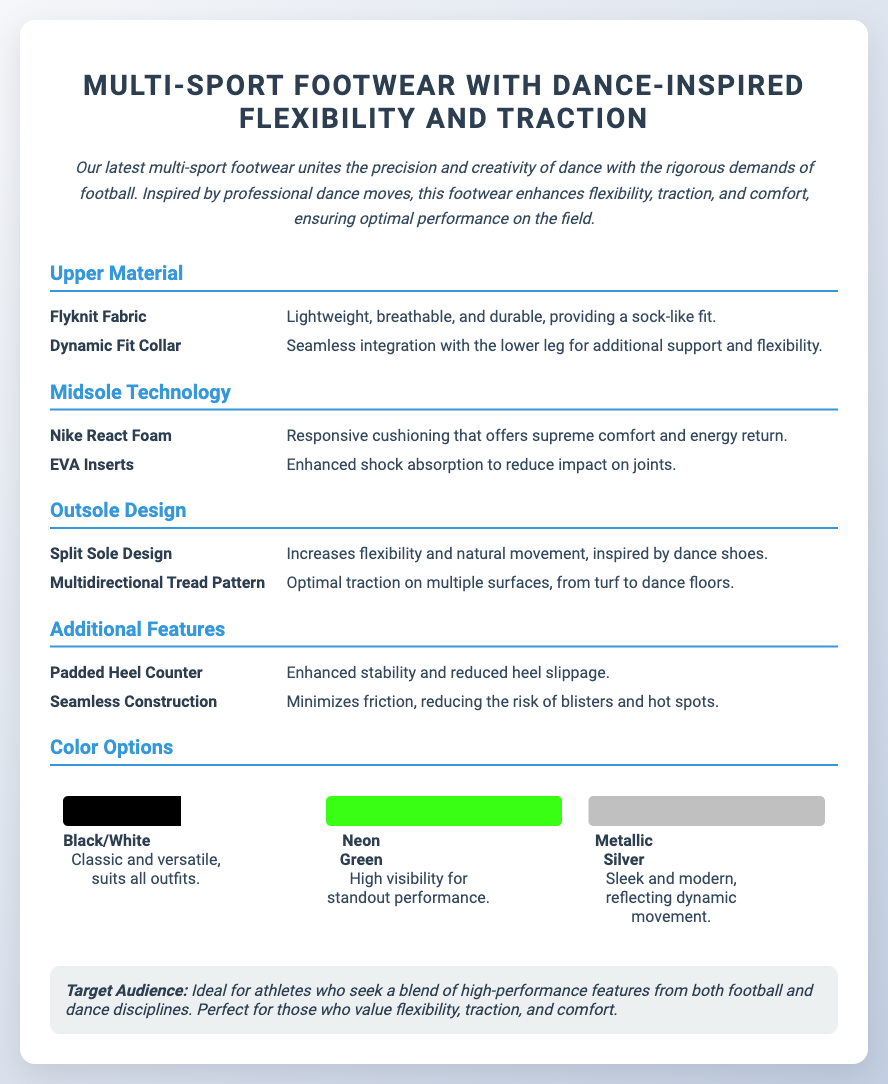What is the main inspiration for the footwear? The footwear is inspired by professional dance moves.
Answer: Dance moves What type of material is the upper made from? The upper material is Flyknit Fabric, which provides a sock-like fit.
Answer: Flyknit Fabric What technology is used in the midsole? The midsole features Nike React Foam for cushioning.
Answer: Nike React Foam What is the purpose of the Split Sole Design? The Split Sole Design increases flexibility and natural movement.
Answer: Flexibility Which color option is described as sleek and modern? The Metallic Silver color option is described as sleek and modern.
Answer: Metallic Silver Who is the target audience for this footwear? The target audience is athletes who seek a blend of high-performance from football and dance.
Answer: Athletes How many color options are mentioned? Three color options are mentioned in the document.
Answer: Three What feature minimizes friction and reduces the risk of blisters? The feature that minimizes friction is Seamless Construction.
Answer: Seamless Construction What is the overall theme of the footwear? The footwear unites the precision and creativity of dance with the demands of football.
Answer: Precision and creativity of dance 